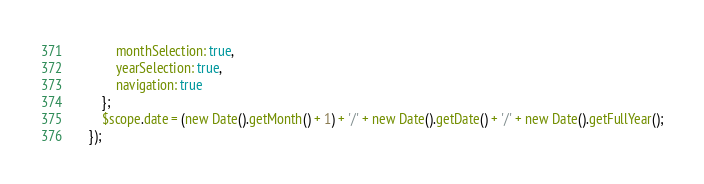<code> <loc_0><loc_0><loc_500><loc_500><_JavaScript_>            monthSelection: true,
            yearSelection: true,
            navigation: true
        };
        $scope.date = (new Date().getMonth() + 1) + '/' + new Date().getDate() + '/' + new Date().getFullYear();
    });
</code> 